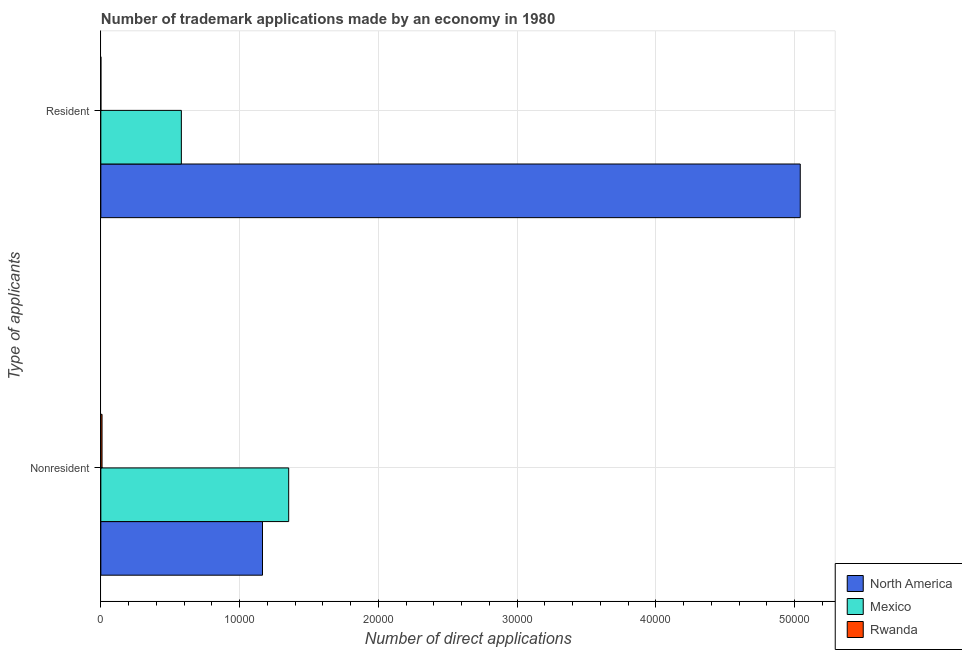How many different coloured bars are there?
Your response must be concise. 3. How many bars are there on the 1st tick from the top?
Your answer should be compact. 3. How many bars are there on the 1st tick from the bottom?
Ensure brevity in your answer.  3. What is the label of the 1st group of bars from the top?
Provide a succinct answer. Resident. What is the number of trademark applications made by residents in Mexico?
Your answer should be very brief. 5803. Across all countries, what is the maximum number of trademark applications made by residents?
Keep it short and to the point. 5.04e+04. Across all countries, what is the minimum number of trademark applications made by non residents?
Offer a terse response. 87. In which country was the number of trademark applications made by residents maximum?
Ensure brevity in your answer.  North America. In which country was the number of trademark applications made by non residents minimum?
Your answer should be compact. Rwanda. What is the total number of trademark applications made by residents in the graph?
Your response must be concise. 5.62e+04. What is the difference between the number of trademark applications made by residents in Mexico and that in North America?
Make the answer very short. -4.46e+04. What is the difference between the number of trademark applications made by residents in Mexico and the number of trademark applications made by non residents in Rwanda?
Your answer should be very brief. 5716. What is the average number of trademark applications made by non residents per country?
Offer a very short reply. 8425. What is the difference between the number of trademark applications made by non residents and number of trademark applications made by residents in Mexico?
Offer a very short reply. 7735. What is the ratio of the number of trademark applications made by residents in North America to that in Rwanda?
Give a very brief answer. 5.04e+04. In how many countries, is the number of trademark applications made by non residents greater than the average number of trademark applications made by non residents taken over all countries?
Give a very brief answer. 2. What does the 3rd bar from the bottom in Resident represents?
Ensure brevity in your answer.  Rwanda. Are all the bars in the graph horizontal?
Ensure brevity in your answer.  Yes. How many countries are there in the graph?
Your answer should be very brief. 3. What is the difference between two consecutive major ticks on the X-axis?
Give a very brief answer. 10000. Are the values on the major ticks of X-axis written in scientific E-notation?
Provide a short and direct response. No. Does the graph contain grids?
Ensure brevity in your answer.  Yes. What is the title of the graph?
Provide a succinct answer. Number of trademark applications made by an economy in 1980. What is the label or title of the X-axis?
Provide a succinct answer. Number of direct applications. What is the label or title of the Y-axis?
Offer a terse response. Type of applicants. What is the Number of direct applications in North America in Nonresident?
Your answer should be very brief. 1.16e+04. What is the Number of direct applications of Mexico in Nonresident?
Your answer should be compact. 1.35e+04. What is the Number of direct applications in North America in Resident?
Offer a very short reply. 5.04e+04. What is the Number of direct applications in Mexico in Resident?
Your answer should be compact. 5803. What is the Number of direct applications of Rwanda in Resident?
Your answer should be compact. 1. Across all Type of applicants, what is the maximum Number of direct applications of North America?
Give a very brief answer. 5.04e+04. Across all Type of applicants, what is the maximum Number of direct applications of Mexico?
Keep it short and to the point. 1.35e+04. Across all Type of applicants, what is the minimum Number of direct applications of North America?
Provide a succinct answer. 1.16e+04. Across all Type of applicants, what is the minimum Number of direct applications of Mexico?
Offer a very short reply. 5803. What is the total Number of direct applications of North America in the graph?
Provide a short and direct response. 6.21e+04. What is the total Number of direct applications of Mexico in the graph?
Give a very brief answer. 1.93e+04. What is the total Number of direct applications of Rwanda in the graph?
Offer a terse response. 88. What is the difference between the Number of direct applications of North America in Nonresident and that in Resident?
Offer a terse response. -3.88e+04. What is the difference between the Number of direct applications in Mexico in Nonresident and that in Resident?
Offer a very short reply. 7735. What is the difference between the Number of direct applications in Rwanda in Nonresident and that in Resident?
Provide a short and direct response. 86. What is the difference between the Number of direct applications in North America in Nonresident and the Number of direct applications in Mexico in Resident?
Offer a terse response. 5847. What is the difference between the Number of direct applications of North America in Nonresident and the Number of direct applications of Rwanda in Resident?
Your answer should be compact. 1.16e+04. What is the difference between the Number of direct applications in Mexico in Nonresident and the Number of direct applications in Rwanda in Resident?
Provide a succinct answer. 1.35e+04. What is the average Number of direct applications of North America per Type of applicants?
Give a very brief answer. 3.10e+04. What is the average Number of direct applications in Mexico per Type of applicants?
Provide a short and direct response. 9670.5. What is the average Number of direct applications of Rwanda per Type of applicants?
Your answer should be very brief. 44. What is the difference between the Number of direct applications of North America and Number of direct applications of Mexico in Nonresident?
Offer a terse response. -1888. What is the difference between the Number of direct applications of North America and Number of direct applications of Rwanda in Nonresident?
Make the answer very short. 1.16e+04. What is the difference between the Number of direct applications in Mexico and Number of direct applications in Rwanda in Nonresident?
Your answer should be very brief. 1.35e+04. What is the difference between the Number of direct applications of North America and Number of direct applications of Mexico in Resident?
Make the answer very short. 4.46e+04. What is the difference between the Number of direct applications in North America and Number of direct applications in Rwanda in Resident?
Provide a short and direct response. 5.04e+04. What is the difference between the Number of direct applications of Mexico and Number of direct applications of Rwanda in Resident?
Offer a terse response. 5802. What is the ratio of the Number of direct applications in North America in Nonresident to that in Resident?
Ensure brevity in your answer.  0.23. What is the ratio of the Number of direct applications in Mexico in Nonresident to that in Resident?
Your response must be concise. 2.33. What is the difference between the highest and the second highest Number of direct applications in North America?
Make the answer very short. 3.88e+04. What is the difference between the highest and the second highest Number of direct applications of Mexico?
Provide a short and direct response. 7735. What is the difference between the highest and the lowest Number of direct applications of North America?
Provide a succinct answer. 3.88e+04. What is the difference between the highest and the lowest Number of direct applications of Mexico?
Keep it short and to the point. 7735. What is the difference between the highest and the lowest Number of direct applications of Rwanda?
Offer a terse response. 86. 